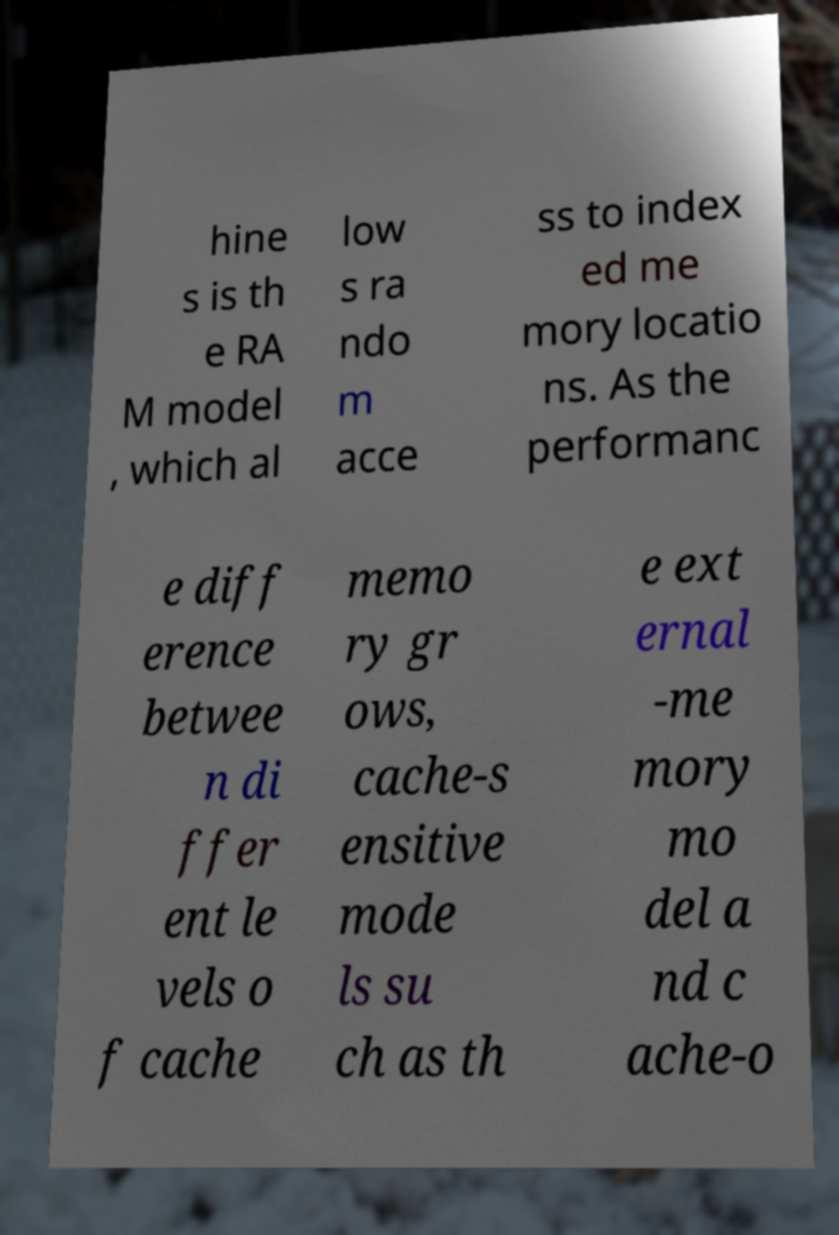Please read and relay the text visible in this image. What does it say? hine s is th e RA M model , which al low s ra ndo m acce ss to index ed me mory locatio ns. As the performanc e diff erence betwee n di ffer ent le vels o f cache memo ry gr ows, cache-s ensitive mode ls su ch as th e ext ernal -me mory mo del a nd c ache-o 